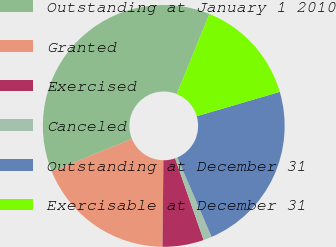<chart> <loc_0><loc_0><loc_500><loc_500><pie_chart><fcel>Outstanding at January 1 2010<fcel>Granted<fcel>Exercised<fcel>Canceled<fcel>Outstanding at December 31<fcel>Exercisable at December 31<nl><fcel>37.33%<fcel>18.67%<fcel>5.51%<fcel>1.13%<fcel>23.06%<fcel>14.29%<nl></chart> 